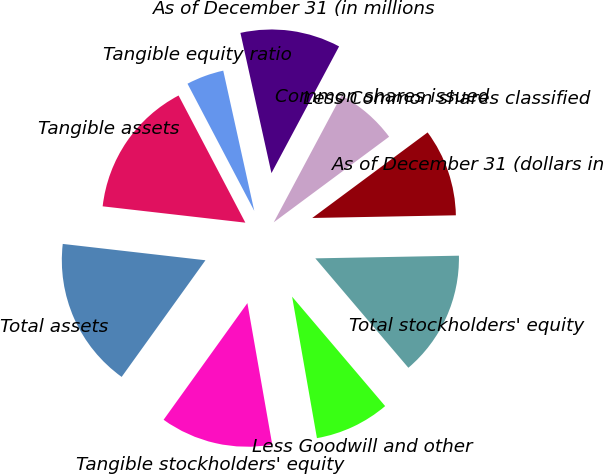Convert chart to OTSL. <chart><loc_0><loc_0><loc_500><loc_500><pie_chart><fcel>As of December 31 (dollars in<fcel>Total stockholders' equity<fcel>Less Goodwill and other<fcel>Tangible stockholders' equity<fcel>Total assets<fcel>Tangible assets<fcel>Tangible equity ratio<fcel>As of December 31 (in millions<fcel>Common shares issued<fcel>Less Common shares classified<nl><fcel>9.86%<fcel>14.08%<fcel>8.45%<fcel>12.68%<fcel>16.9%<fcel>15.49%<fcel>4.23%<fcel>11.27%<fcel>7.04%<fcel>0.0%<nl></chart> 